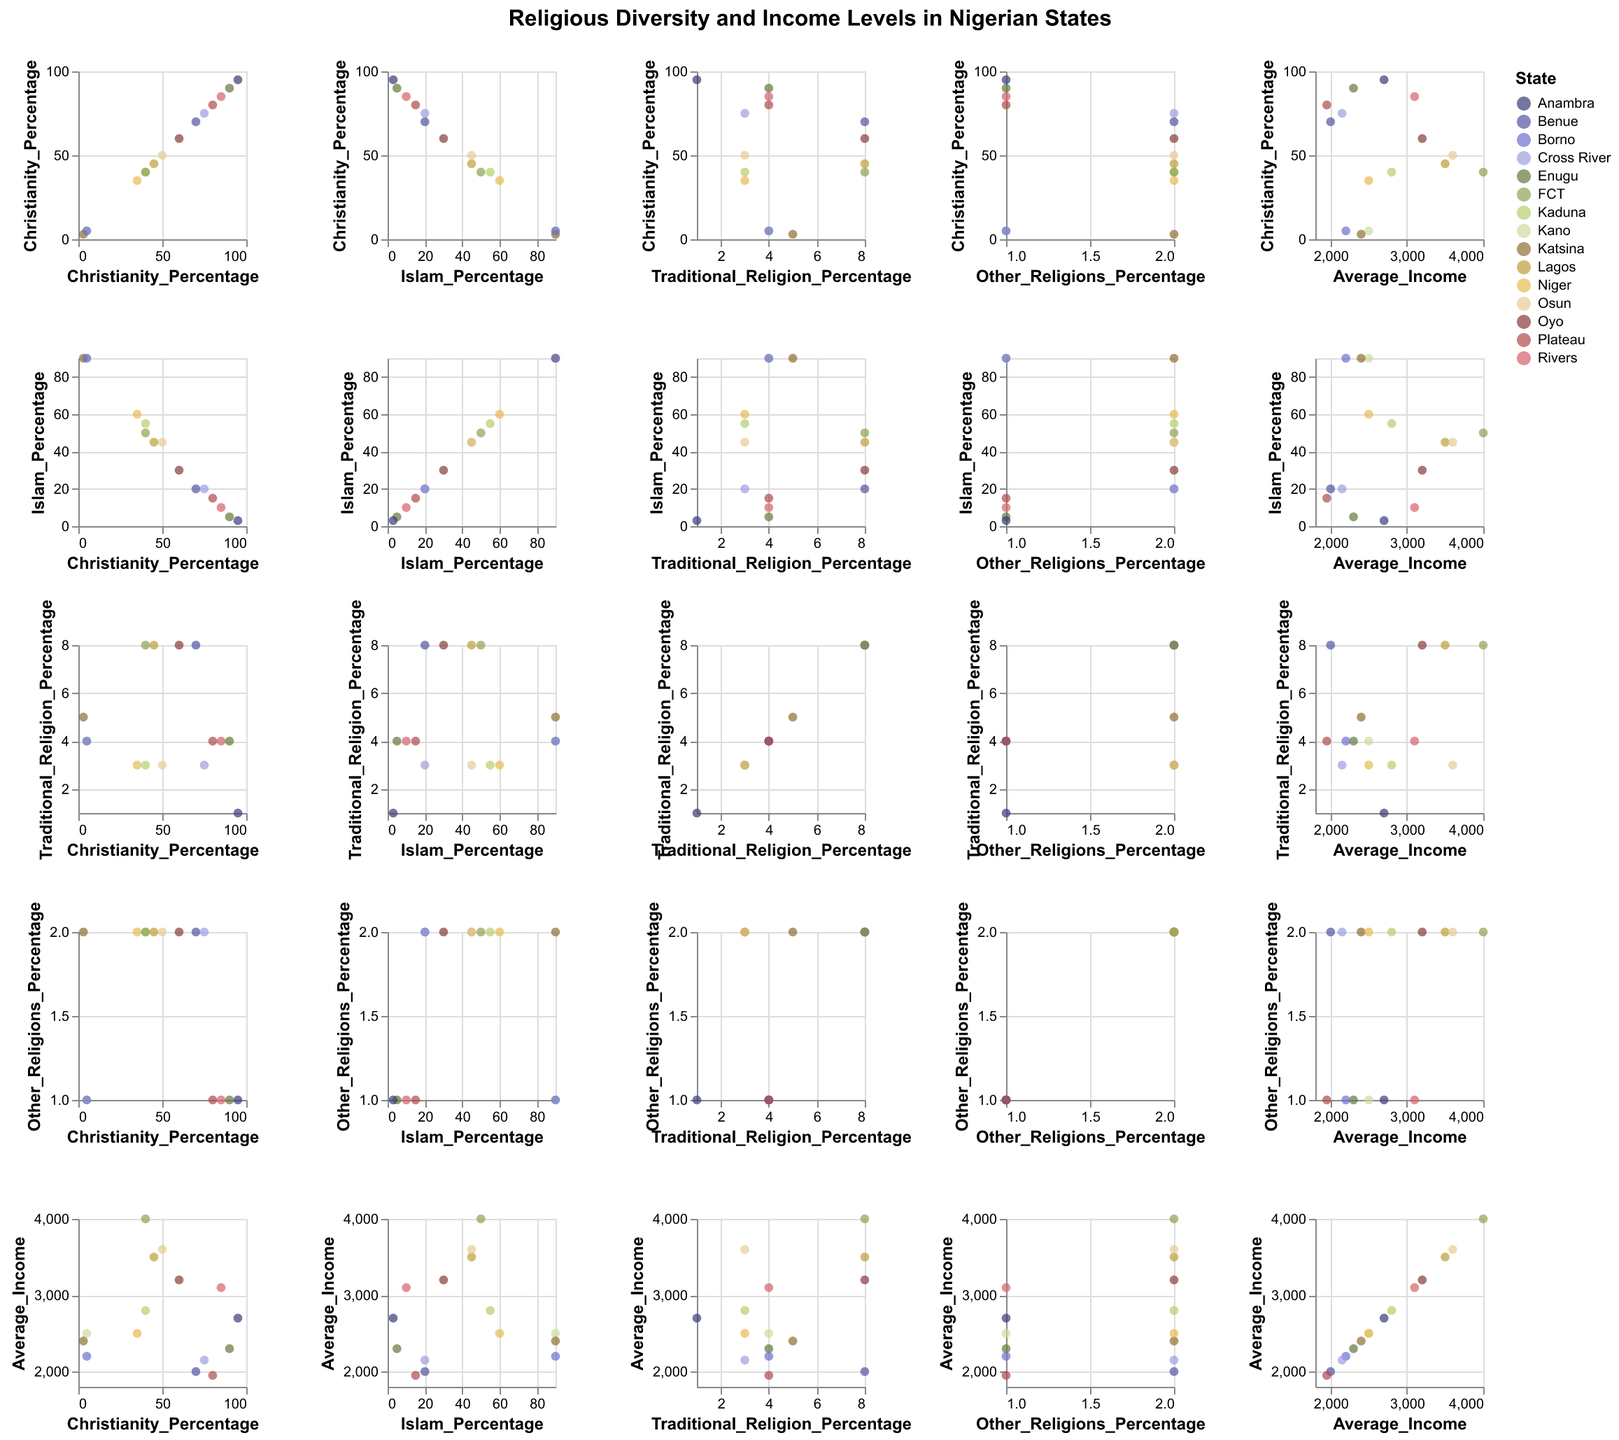Which state has the highest average income? Look at the scatter plot matrix and locate the data point with the highest value in the "Average_Income" axis. The FCT has the highest average income of 4000.
Answer: FCT Which state has the lowest percentage of Christianity? Locate the scatter plot corresponding to the "Christianity_Percentage" axis. Kano and Katsina have the lowest combined Christian percentages at 3%.
Answer: Katsina and Kano Are there any states with equal percentages of Christianity and Islam? Look for points along a line y = x on the Christianity vs. Islam scatter plot. Lagos and Osun have equal percentages of Christianity and Islam at 45%.
Answer: Lagos and Osun How many states have a Traditional Religion percentage higher than 5%? Identify and count points above the 5% mark on the "Traditional_Religion_Percentage" axis. The states are Lagos, Oyo, Kaduna, Benue, and FCT, totaling five states.
Answer: 5 Which state has the highest percentage of Christianity and what is its average income? Find the state with the maximum percentage on the "Christianity_Percentage" axis. Anambra has 95%, and its average income is 2700.
Answer: Anambra, 2700 What’s the relationship between income and the percentage of Christians in FCT? Observe the data points in the Christianity vs. Average Income scatter plot. FCT has 40% Christians and an average income of 4000.
Answer: 40% Christians, 4000 average income Compare the percentage of Traditional Religion adherence in Lagos and Kaduna. Which state has a higher percentage? Locate both states on the scatter plot of Traditional_Religion_Percentage vs. State and compare the values. Lagos has 8%, and Kaduna has 3%.
Answer: Lagos Is there a strong correlation between Average_Income and Islam_Percentage? Look at the data points' trend in the Islam_Percentage vs. Average_Income scatter plot to determine if a pattern or correlation exists. There appears to be no strong correlation as the points are scattered without a clear trend.
Answer: No strong correlation 